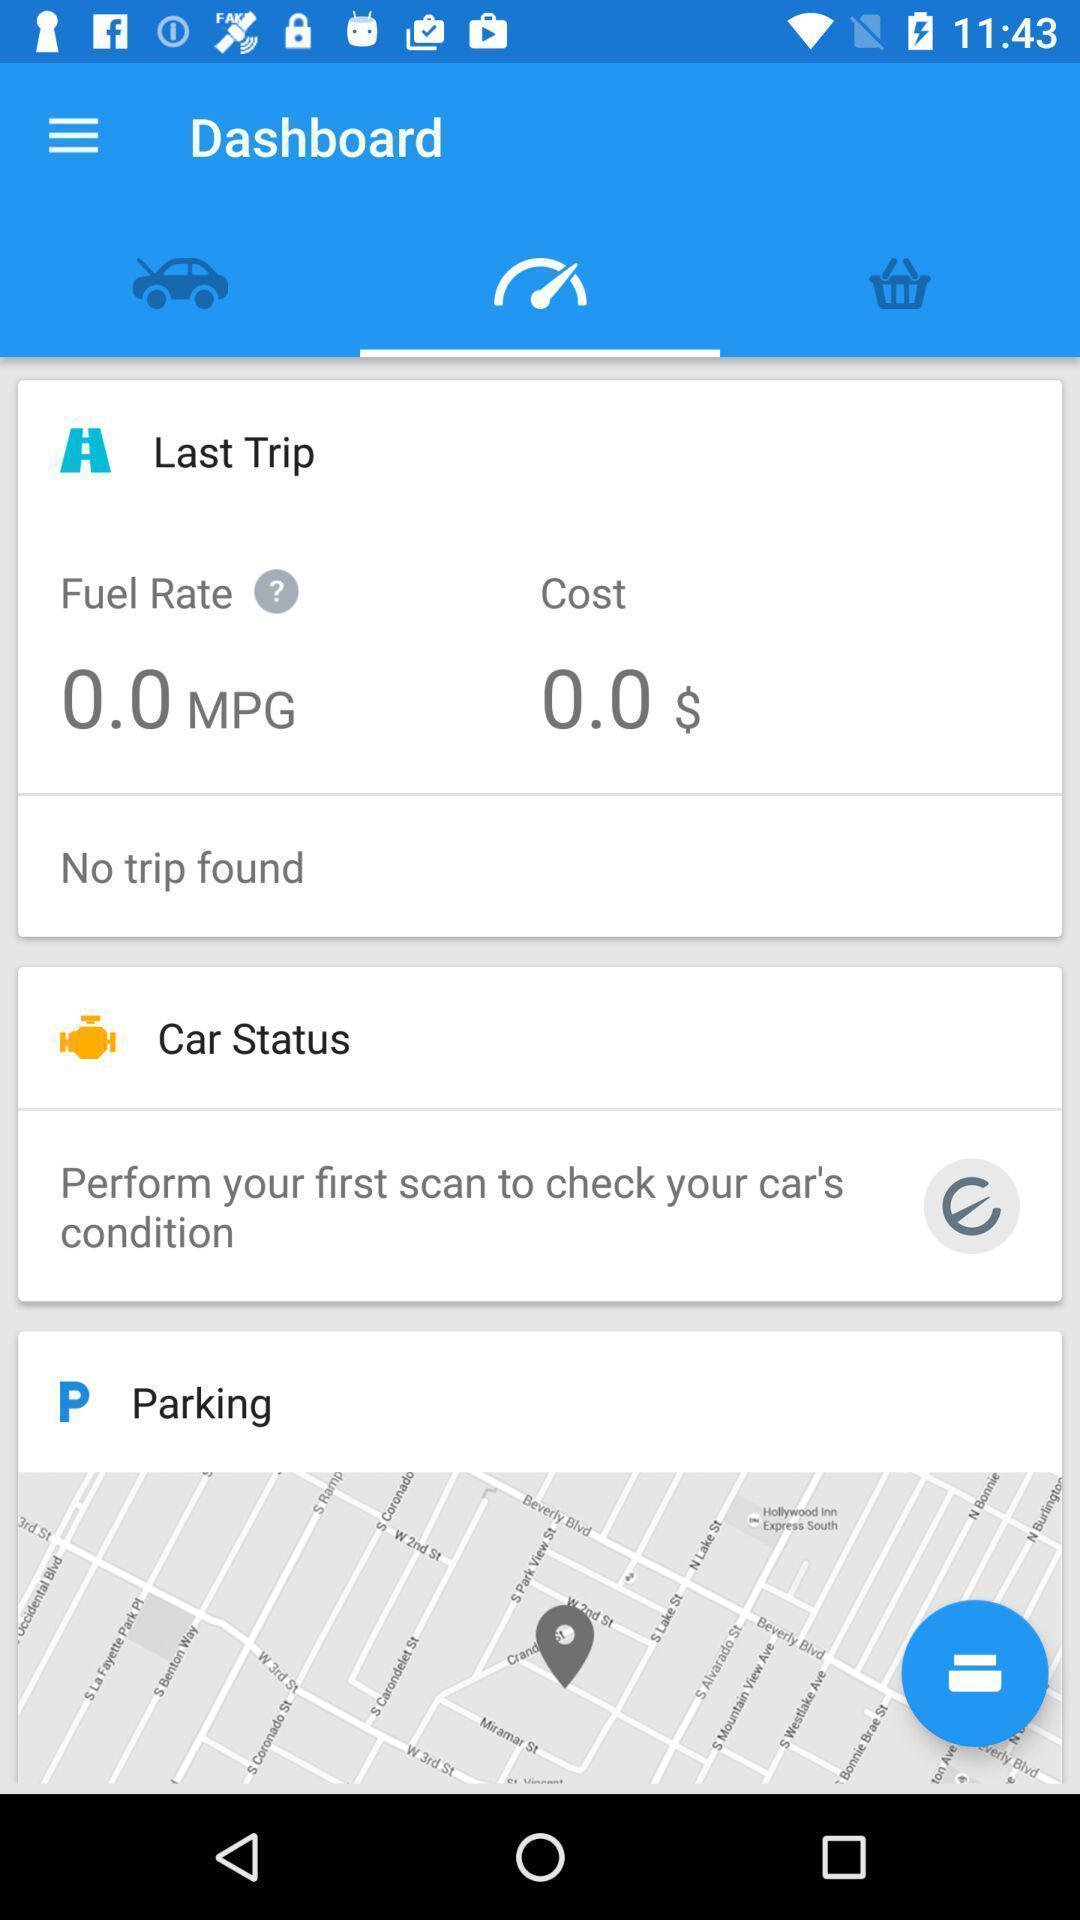Tell me what you see in this picture. Screen shows about dash board. 